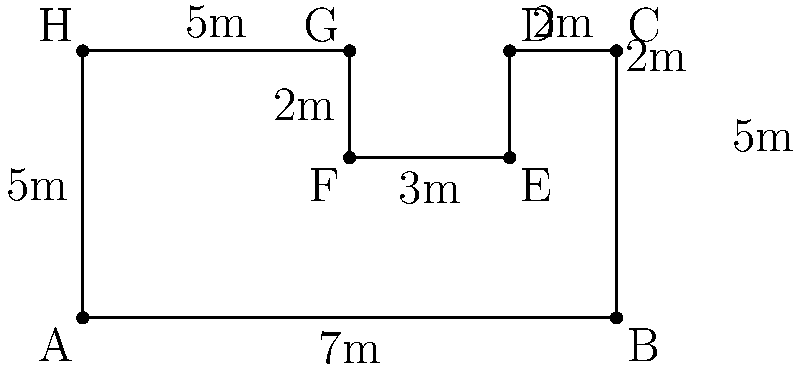You are considering purchasing a luxury property in Australia with an irregularly shaped swimming pool. The pool's shape and dimensions (in meters) are shown in the diagram above. What is the perimeter of this swimming pool? To find the perimeter of the irregularly shaped swimming pool, we need to add up the lengths of all sides:

1. Side AB: 7m
2. Side BC: 5m
3. Side CD: 2m
4. Side DE: 2m
5. Side EF: 3m
6. Side FG: 2m
7. Side GH: 5m
8. Side HA: 5m

Let's add these lengths:

$$\text{Perimeter} = 7 + 5 + 2 + 2 + 3 + 2 + 5 + 5 = 31\text{ m}$$

Therefore, the perimeter of the swimming pool is 31 meters.
Answer: 31 m 